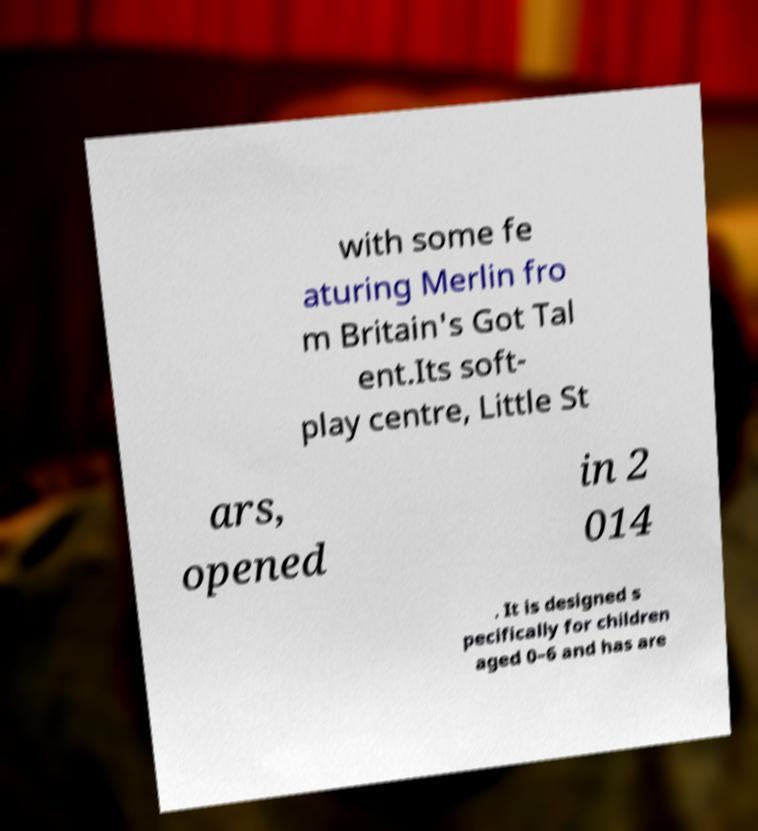Could you assist in decoding the text presented in this image and type it out clearly? with some fe aturing Merlin fro m Britain's Got Tal ent.Its soft- play centre, Little St ars, opened in 2 014 . It is designed s pecifically for children aged 0–6 and has are 